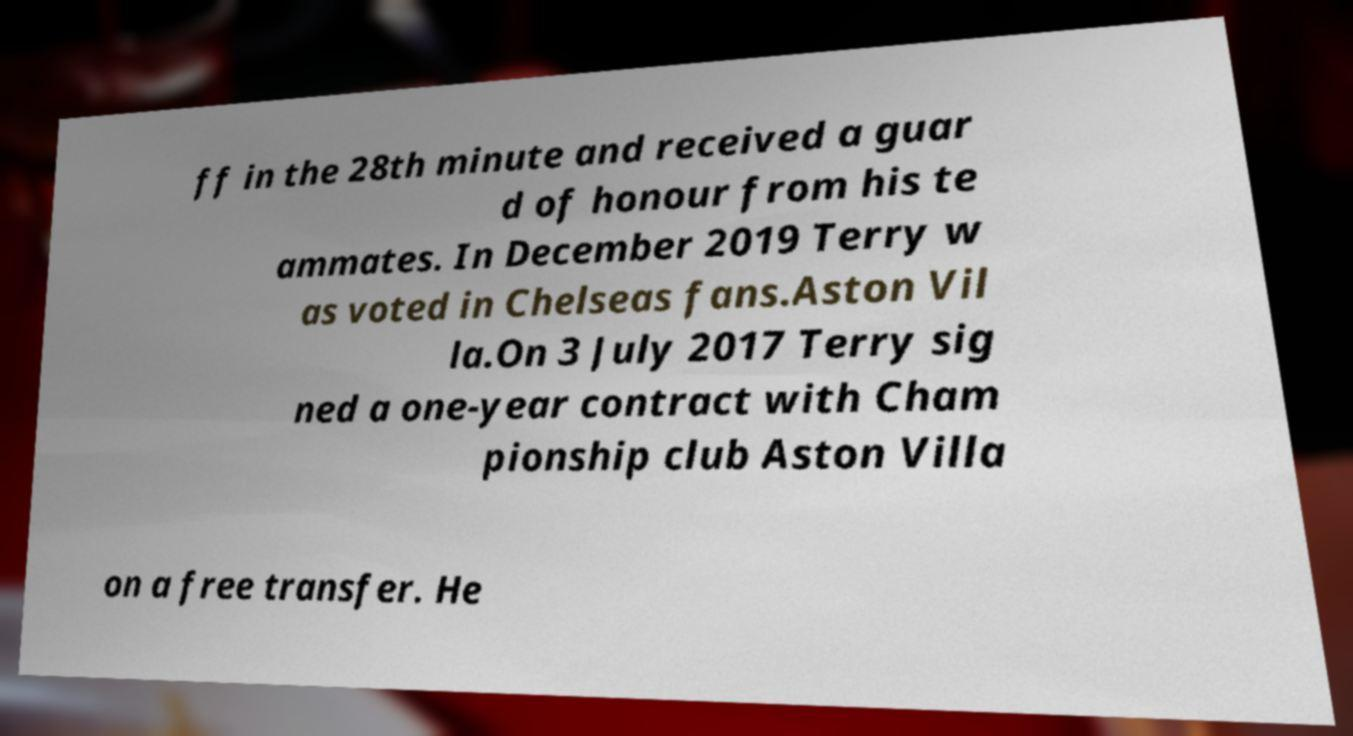Can you accurately transcribe the text from the provided image for me? ff in the 28th minute and received a guar d of honour from his te ammates. In December 2019 Terry w as voted in Chelseas fans.Aston Vil la.On 3 July 2017 Terry sig ned a one-year contract with Cham pionship club Aston Villa on a free transfer. He 